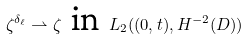Convert formula to latex. <formula><loc_0><loc_0><loc_500><loc_500>\zeta ^ { \delta _ { \ell } } \rightharpoonup \zeta \, \text { in } \, L _ { 2 } ( ( 0 , t ) , H ^ { - 2 } ( D ) )</formula> 